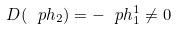<formula> <loc_0><loc_0><loc_500><loc_500>D ( \ p h _ { 2 } ) = - \ p h ^ { 1 } _ { 1 } \ne 0</formula> 